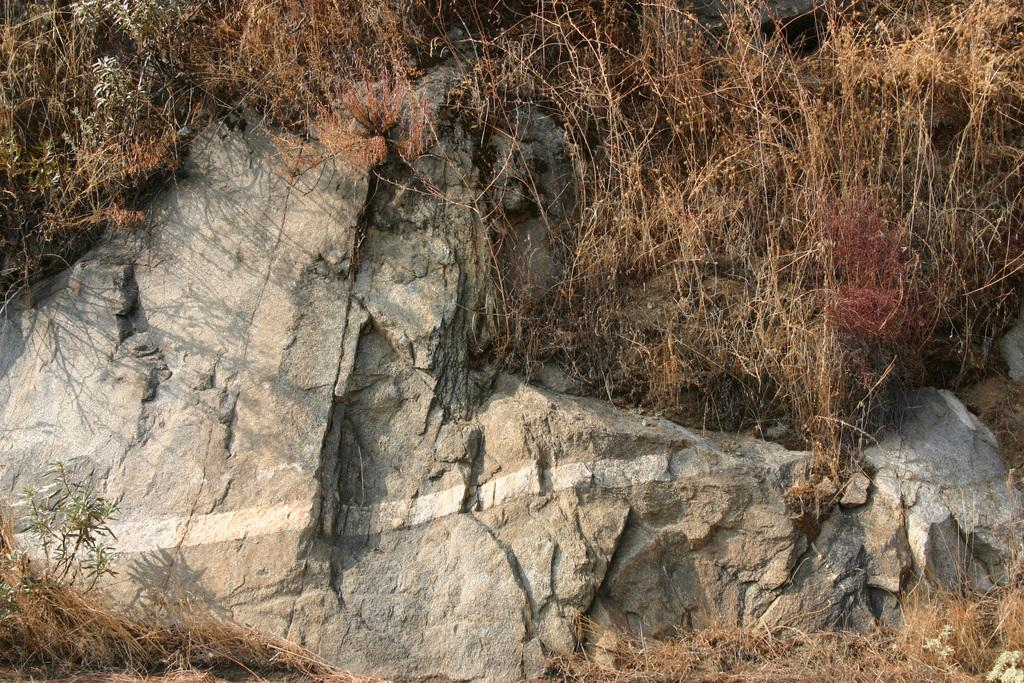What type of object is in the image? There is a stone in the image. What type of vegetation is present in the image? There is grass in the image. Can you tell me how many times the stone runs across the grass in the image? There is no indication of the stone running or moving in the image. 